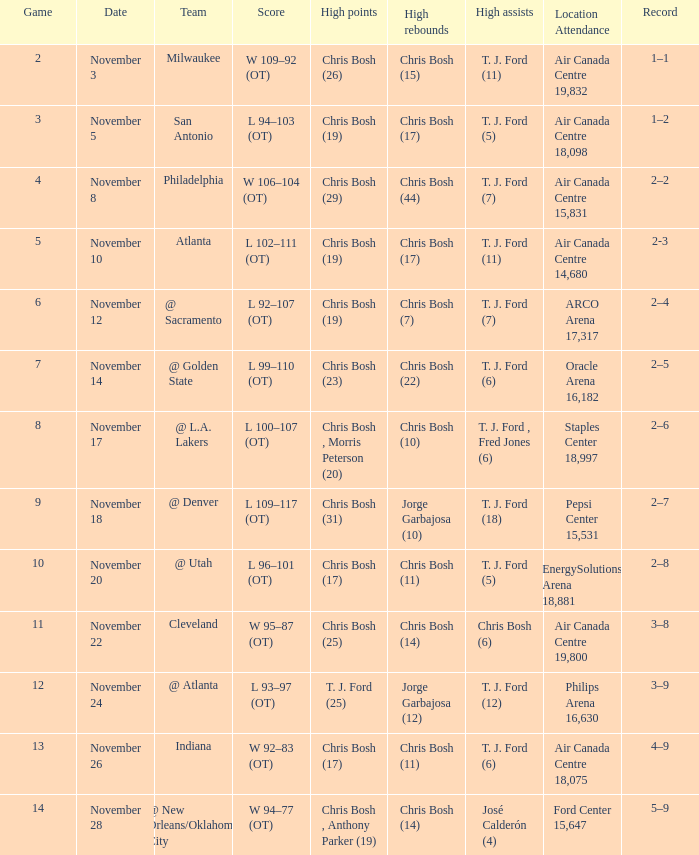Who was the top scorer in game 4? Chris Bosh (29). Write the full table. {'header': ['Game', 'Date', 'Team', 'Score', 'High points', 'High rebounds', 'High assists', 'Location Attendance', 'Record'], 'rows': [['2', 'November 3', 'Milwaukee', 'W 109–92 (OT)', 'Chris Bosh (26)', 'Chris Bosh (15)', 'T. J. Ford (11)', 'Air Canada Centre 19,832', '1–1'], ['3', 'November 5', 'San Antonio', 'L 94–103 (OT)', 'Chris Bosh (19)', 'Chris Bosh (17)', 'T. J. Ford (5)', 'Air Canada Centre 18,098', '1–2'], ['4', 'November 8', 'Philadelphia', 'W 106–104 (OT)', 'Chris Bosh (29)', 'Chris Bosh (44)', 'T. J. Ford (7)', 'Air Canada Centre 15,831', '2–2'], ['5', 'November 10', 'Atlanta', 'L 102–111 (OT)', 'Chris Bosh (19)', 'Chris Bosh (17)', 'T. J. Ford (11)', 'Air Canada Centre 14,680', '2-3'], ['6', 'November 12', '@ Sacramento', 'L 92–107 (OT)', 'Chris Bosh (19)', 'Chris Bosh (7)', 'T. J. Ford (7)', 'ARCO Arena 17,317', '2–4'], ['7', 'November 14', '@ Golden State', 'L 99–110 (OT)', 'Chris Bosh (23)', 'Chris Bosh (22)', 'T. J. Ford (6)', 'Oracle Arena 16,182', '2–5'], ['8', 'November 17', '@ L.A. Lakers', 'L 100–107 (OT)', 'Chris Bosh , Morris Peterson (20)', 'Chris Bosh (10)', 'T. J. Ford , Fred Jones (6)', 'Staples Center 18,997', '2–6'], ['9', 'November 18', '@ Denver', 'L 109–117 (OT)', 'Chris Bosh (31)', 'Jorge Garbajosa (10)', 'T. J. Ford (18)', 'Pepsi Center 15,531', '2–7'], ['10', 'November 20', '@ Utah', 'L 96–101 (OT)', 'Chris Bosh (17)', 'Chris Bosh (11)', 'T. J. Ford (5)', 'EnergySolutions Arena 18,881', '2–8'], ['11', 'November 22', 'Cleveland', 'W 95–87 (OT)', 'Chris Bosh (25)', 'Chris Bosh (14)', 'Chris Bosh (6)', 'Air Canada Centre 19,800', '3–8'], ['12', 'November 24', '@ Atlanta', 'L 93–97 (OT)', 'T. J. Ford (25)', 'Jorge Garbajosa (12)', 'T. J. Ford (12)', 'Philips Arena 16,630', '3–9'], ['13', 'November 26', 'Indiana', 'W 92–83 (OT)', 'Chris Bosh (17)', 'Chris Bosh (11)', 'T. J. Ford (6)', 'Air Canada Centre 18,075', '4–9'], ['14', 'November 28', '@ New Orleans/Oklahoma City', 'W 94–77 (OT)', 'Chris Bosh , Anthony Parker (19)', 'Chris Bosh (14)', 'José Calderón (4)', 'Ford Center 15,647', '5–9']]} 